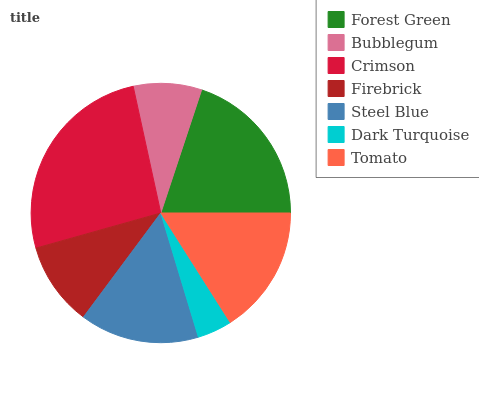Is Dark Turquoise the minimum?
Answer yes or no. Yes. Is Crimson the maximum?
Answer yes or no. Yes. Is Bubblegum the minimum?
Answer yes or no. No. Is Bubblegum the maximum?
Answer yes or no. No. Is Forest Green greater than Bubblegum?
Answer yes or no. Yes. Is Bubblegum less than Forest Green?
Answer yes or no. Yes. Is Bubblegum greater than Forest Green?
Answer yes or no. No. Is Forest Green less than Bubblegum?
Answer yes or no. No. Is Steel Blue the high median?
Answer yes or no. Yes. Is Steel Blue the low median?
Answer yes or no. Yes. Is Dark Turquoise the high median?
Answer yes or no. No. Is Firebrick the low median?
Answer yes or no. No. 